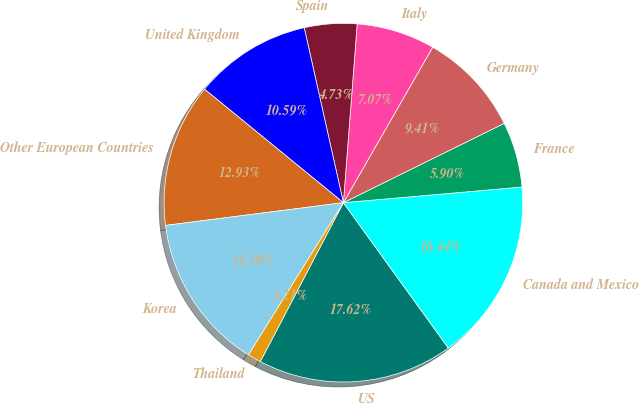Convert chart to OTSL. <chart><loc_0><loc_0><loc_500><loc_500><pie_chart><fcel>US<fcel>Canada and Mexico<fcel>France<fcel>Germany<fcel>Italy<fcel>Spain<fcel>United Kingdom<fcel>Other European Countries<fcel>Korea<fcel>Thailand<nl><fcel>17.62%<fcel>16.44%<fcel>5.9%<fcel>9.41%<fcel>7.07%<fcel>4.73%<fcel>10.59%<fcel>12.93%<fcel>14.1%<fcel>1.21%<nl></chart> 